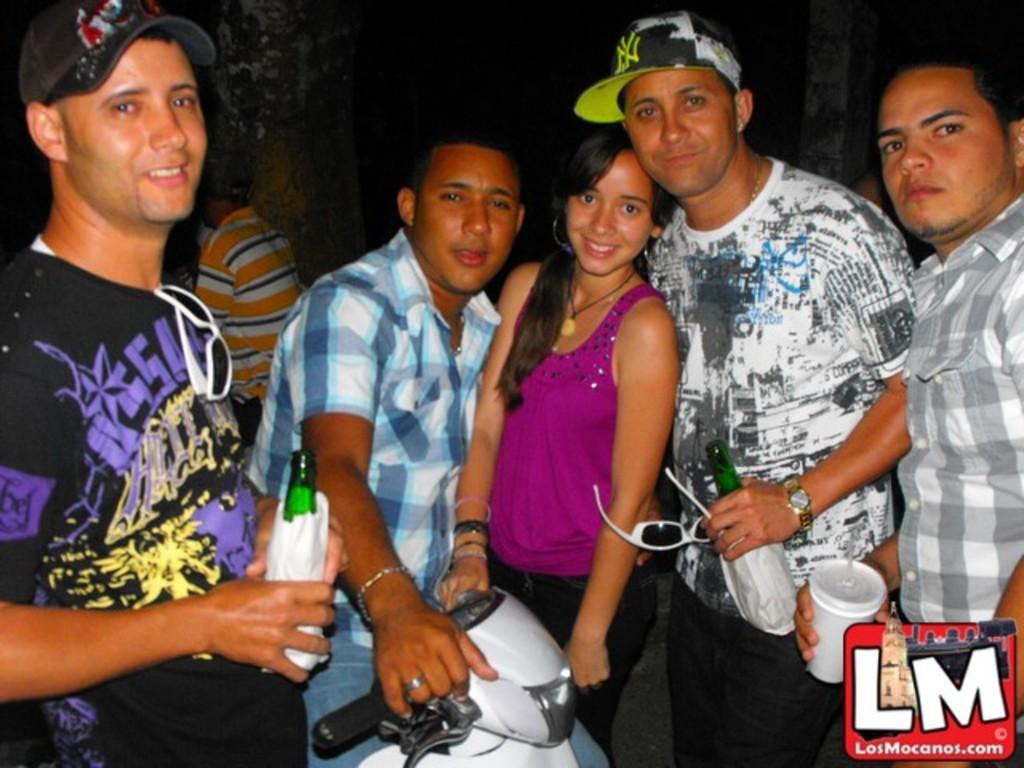How would you summarize this image in a sentence or two? In this image there are group of persons standing and smiling. In the center there is a bike which is white in colour. On the left side there is a person standing and holding a bottle in his hand. On the right side there is a man standing and holding a glass in his hand. In the center there is a man standing and holding bottle and goggles in his hand and smiling. In the background there is wall and there is a person visible. 